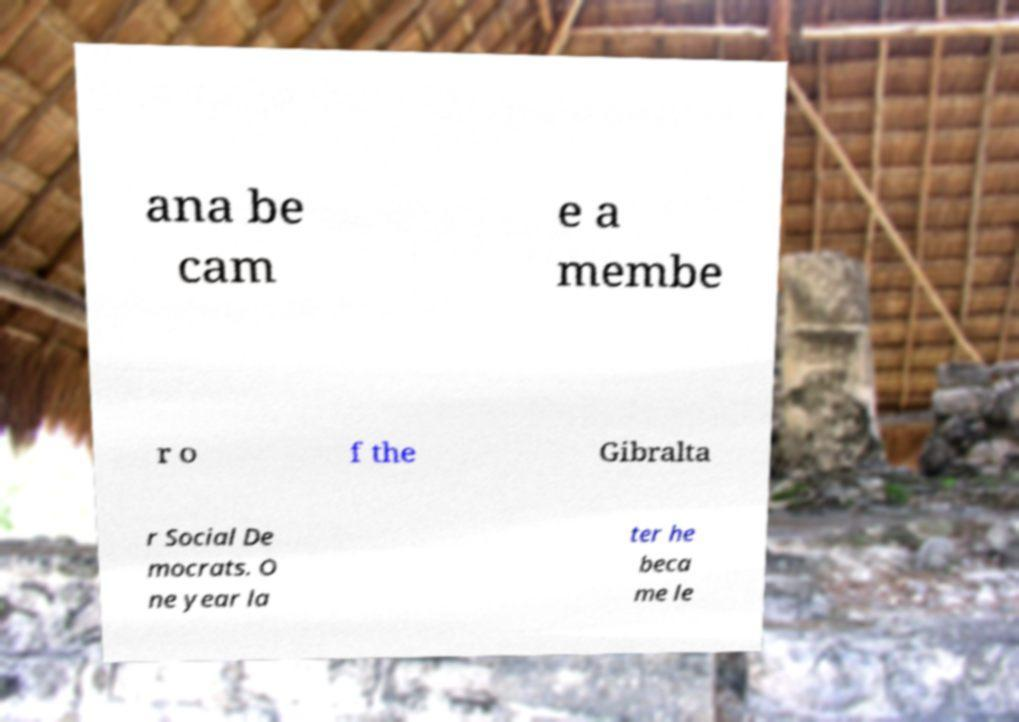Can you accurately transcribe the text from the provided image for me? ana be cam e a membe r o f the Gibralta r Social De mocrats. O ne year la ter he beca me le 